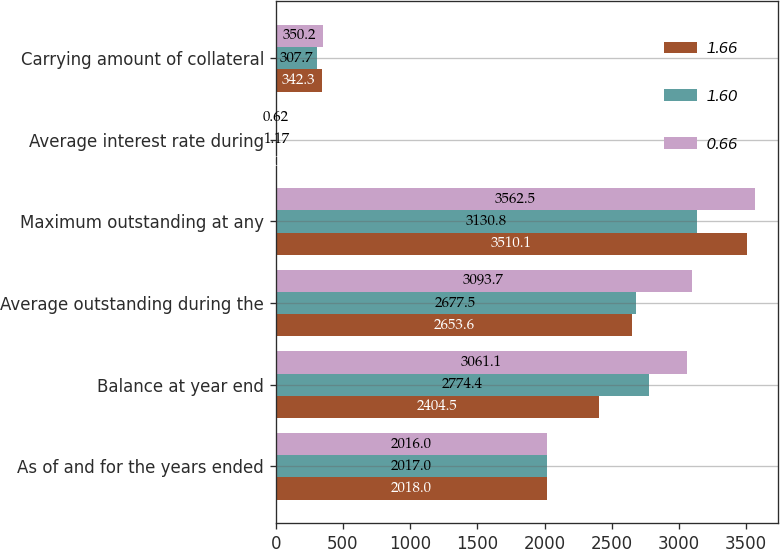<chart> <loc_0><loc_0><loc_500><loc_500><stacked_bar_chart><ecel><fcel>As of and for the years ended<fcel>Balance at year end<fcel>Average outstanding during the<fcel>Maximum outstanding at any<fcel>Average interest rate during<fcel>Carrying amount of collateral<nl><fcel>1.66<fcel>2018<fcel>2404.5<fcel>2653.6<fcel>3510.1<fcel>2.05<fcel>342.3<nl><fcel>1.6<fcel>2017<fcel>2774.4<fcel>2677.5<fcel>3130.8<fcel>1.17<fcel>307.7<nl><fcel>0.66<fcel>2016<fcel>3061.1<fcel>3093.7<fcel>3562.5<fcel>0.62<fcel>350.2<nl></chart> 